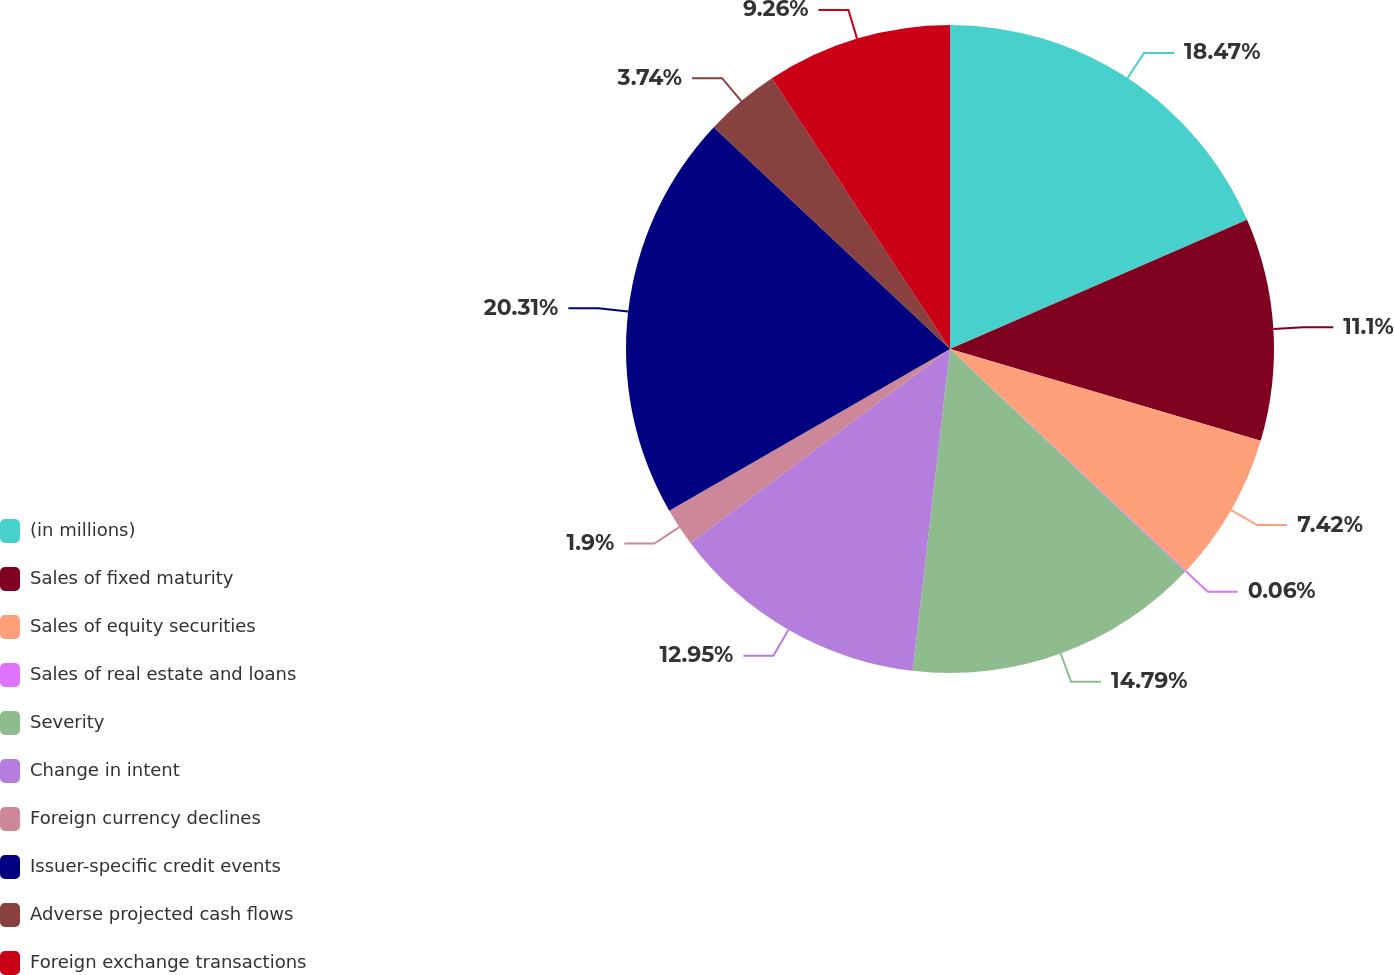Convert chart. <chart><loc_0><loc_0><loc_500><loc_500><pie_chart><fcel>(in millions)<fcel>Sales of fixed maturity<fcel>Sales of equity securities<fcel>Sales of real estate and loans<fcel>Severity<fcel>Change in intent<fcel>Foreign currency declines<fcel>Issuer-specific credit events<fcel>Adverse projected cash flows<fcel>Foreign exchange transactions<nl><fcel>18.46%<fcel>11.1%<fcel>7.42%<fcel>0.06%<fcel>14.78%<fcel>12.94%<fcel>1.9%<fcel>20.3%<fcel>3.74%<fcel>9.26%<nl></chart> 